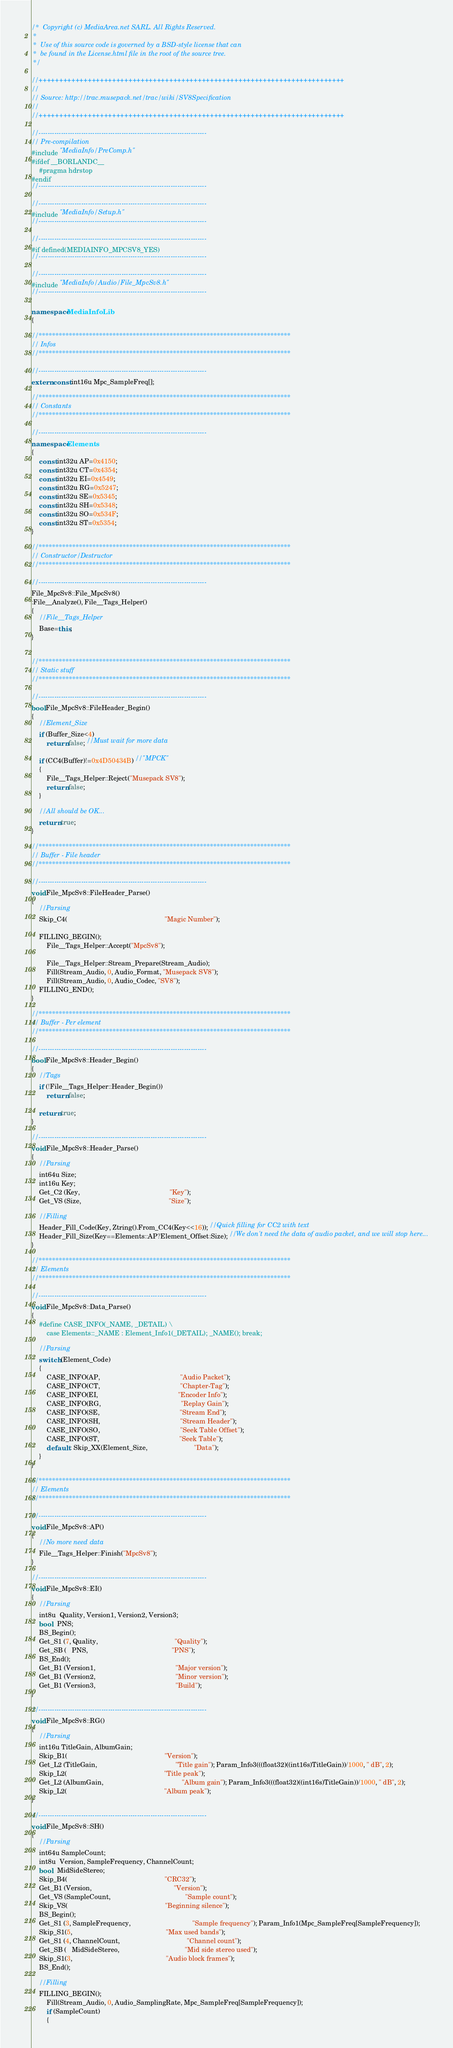<code> <loc_0><loc_0><loc_500><loc_500><_C++_>/*  Copyright (c) MediaArea.net SARL. All Rights Reserved.
 *
 *  Use of this source code is governed by a BSD-style license that can
 *  be found in the License.html file in the root of the source tree.
 */

//+++++++++++++++++++++++++++++++++++++++++++++++++++++++++++++++++++++++++++
//
// Source: http://trac.musepack.net/trac/wiki/SV8Specification
//
//+++++++++++++++++++++++++++++++++++++++++++++++++++++++++++++++++++++++++++

//---------------------------------------------------------------------------
// Pre-compilation
#include "MediaInfo/PreComp.h"
#ifdef __BORLANDC__
    #pragma hdrstop
#endif
//---------------------------------------------------------------------------

//---------------------------------------------------------------------------
#include "MediaInfo/Setup.h"
//---------------------------------------------------------------------------

//---------------------------------------------------------------------------
#if defined(MEDIAINFO_MPCSV8_YES)
//---------------------------------------------------------------------------

//---------------------------------------------------------------------------
#include "MediaInfo/Audio/File_MpcSv8.h"
//---------------------------------------------------------------------------

namespace MediaInfoLib
{

//***************************************************************************
// Infos
//***************************************************************************

//---------------------------------------------------------------------------
extern const int16u Mpc_SampleFreq[];

//***************************************************************************
// Constants
//***************************************************************************

//---------------------------------------------------------------------------
namespace Elements
{
    const int32u AP=0x4150;
    const int32u CT=0x4354;
    const int32u EI=0x4549;
    const int32u RG=0x5247;
    const int32u SE=0x5345;
    const int32u SH=0x5348;
    const int32u SO=0x534F;
    const int32u ST=0x5354;
}

//***************************************************************************
// Constructor/Destructor
//***************************************************************************

//---------------------------------------------------------------------------
File_MpcSv8::File_MpcSv8()
:File__Analyze(), File__Tags_Helper()
{
    //File__Tags_Helper
    Base=this;
}


//***************************************************************************
// Static stuff
//***************************************************************************

//---------------------------------------------------------------------------
bool File_MpcSv8::FileHeader_Begin()
{
    //Element_Size
    if (Buffer_Size<4)
        return false; //Must wait for more data

    if (CC4(Buffer)!=0x4D50434B) //"MPCK"
    {
        File__Tags_Helper::Reject("Musepack SV8");
        return false;
    }

    //All should be OK...
    return true;
}

//***************************************************************************
// Buffer - File header
//***************************************************************************

//---------------------------------------------------------------------------
void File_MpcSv8::FileHeader_Parse()
{
    //Parsing
    Skip_C4(                                                    "Magic Number");

    FILLING_BEGIN();
        File__Tags_Helper::Accept("MpcSv8");

        File__Tags_Helper::Stream_Prepare(Stream_Audio);
        Fill(Stream_Audio, 0, Audio_Format, "Musepack SV8");
        Fill(Stream_Audio, 0, Audio_Codec, "SV8");
    FILLING_END();
}

//***************************************************************************
// Buffer - Per element
//***************************************************************************

//---------------------------------------------------------------------------
bool File_MpcSv8::Header_Begin()
{
    //Tags
    if (!File__Tags_Helper::Header_Begin())
        return false;

    return true;
}

//---------------------------------------------------------------------------
void File_MpcSv8::Header_Parse()
{
    //Parsing
    int64u Size;
    int16u Key;
    Get_C2 (Key,                                                "Key");
    Get_VS (Size,                                               "Size");

    //Filling
    Header_Fill_Code(Key, Ztring().From_CC4(Key<<16)); //Quick filling for CC2 with text
    Header_Fill_Size(Key==Elements::AP?Element_Offset:Size); //We don't need the data of audio packet, and we will stop here...
}

//***************************************************************************
// Elements
//***************************************************************************

//---------------------------------------------------------------------------
void File_MpcSv8::Data_Parse()
{
    #define CASE_INFO(_NAME, _DETAIL) \
        case Elements::_NAME : Element_Info1(_DETAIL); _NAME(); break;

    //Parsing
    switch (Element_Code)
    {
        CASE_INFO(AP,                                           "Audio Packet");
        CASE_INFO(CT,                                           "Chapter-Tag");
        CASE_INFO(EI,                                           "Encoder Info");
        CASE_INFO(RG,                                           "Replay Gain");
        CASE_INFO(SE,                                           "Stream End");
        CASE_INFO(SH,                                           "Stream Header");
        CASE_INFO(SO,                                           "Seek Table Offset");
        CASE_INFO(ST,                                           "Seek Table");
        default : Skip_XX(Element_Size,                         "Data");
    }
}

//***************************************************************************
// Elements
//***************************************************************************

//---------------------------------------------------------------------------
void File_MpcSv8::AP()
{
    //No more need data
    File__Tags_Helper::Finish("MpcSv8");
}

//---------------------------------------------------------------------------
void File_MpcSv8::EI()
{
    //Parsing
    int8u  Quality, Version1, Version2, Version3;
    bool   PNS;
    BS_Begin();
    Get_S1 (7, Quality,                                         "Quality");
    Get_SB (   PNS,                                             "PNS");
    BS_End();
    Get_B1 (Version1,                                           "Major version");
    Get_B1 (Version2,                                           "Minor version");
    Get_B1 (Version3,                                           "Build");
}

//---------------------------------------------------------------------------
void File_MpcSv8::RG()
{
    //Parsing
    int16u TitleGain, AlbumGain;
    Skip_B1(                                                    "Version");
    Get_L2 (TitleGain,                                          "Title gain"); Param_Info3(((float32)((int16s)TitleGain))/1000, " dB", 2);
    Skip_L2(                                                    "Title peak");
    Get_L2 (AlbumGain,                                          "Album gain"); Param_Info3(((float32)((int16s)TitleGain))/1000, " dB", 2);
    Skip_L2(                                                    "Album peak");
}

//---------------------------------------------------------------------------
void File_MpcSv8::SH()
{
    //Parsing
    int64u SampleCount;
    int8u  Version, SampleFrequency, ChannelCount;
    bool   MidSideStereo;
    Skip_B4(                                                    "CRC32");
    Get_B1 (Version,                                            "Version");
    Get_VS (SampleCount,                                        "Sample count");
    Skip_VS(                                                    "Beginning silence");
    BS_Begin();
    Get_S1 (3, SampleFrequency,                                 "Sample frequency"); Param_Info1(Mpc_SampleFreq[SampleFrequency]);
    Skip_S1(5,                                                  "Max used bands");
    Get_S1 (4, ChannelCount,                                    "Channel count");
    Get_SB (   MidSideStereo,                                   "Mid side stereo used");
    Skip_S1(3,                                                  "Audio block frames");
    BS_End();

    //Filling
    FILLING_BEGIN();
        Fill(Stream_Audio, 0, Audio_SamplingRate, Mpc_SampleFreq[SampleFrequency]);
        if (SampleCount)
        {</code> 